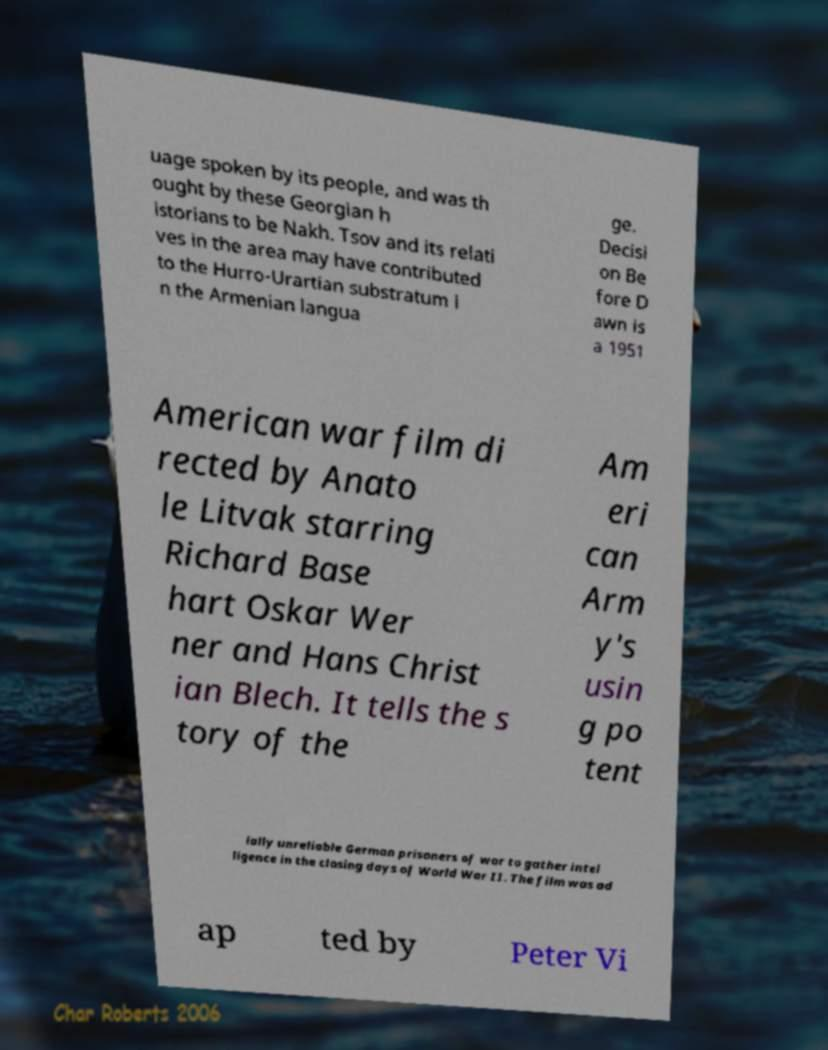Could you extract and type out the text from this image? uage spoken by its people, and was th ought by these Georgian h istorians to be Nakh. Tsov and its relati ves in the area may have contributed to the Hurro-Urartian substratum i n the Armenian langua ge. Decisi on Be fore D awn is a 1951 American war film di rected by Anato le Litvak starring Richard Base hart Oskar Wer ner and Hans Christ ian Blech. It tells the s tory of the Am eri can Arm y's usin g po tent ially unreliable German prisoners of war to gather intel ligence in the closing days of World War II. The film was ad ap ted by Peter Vi 